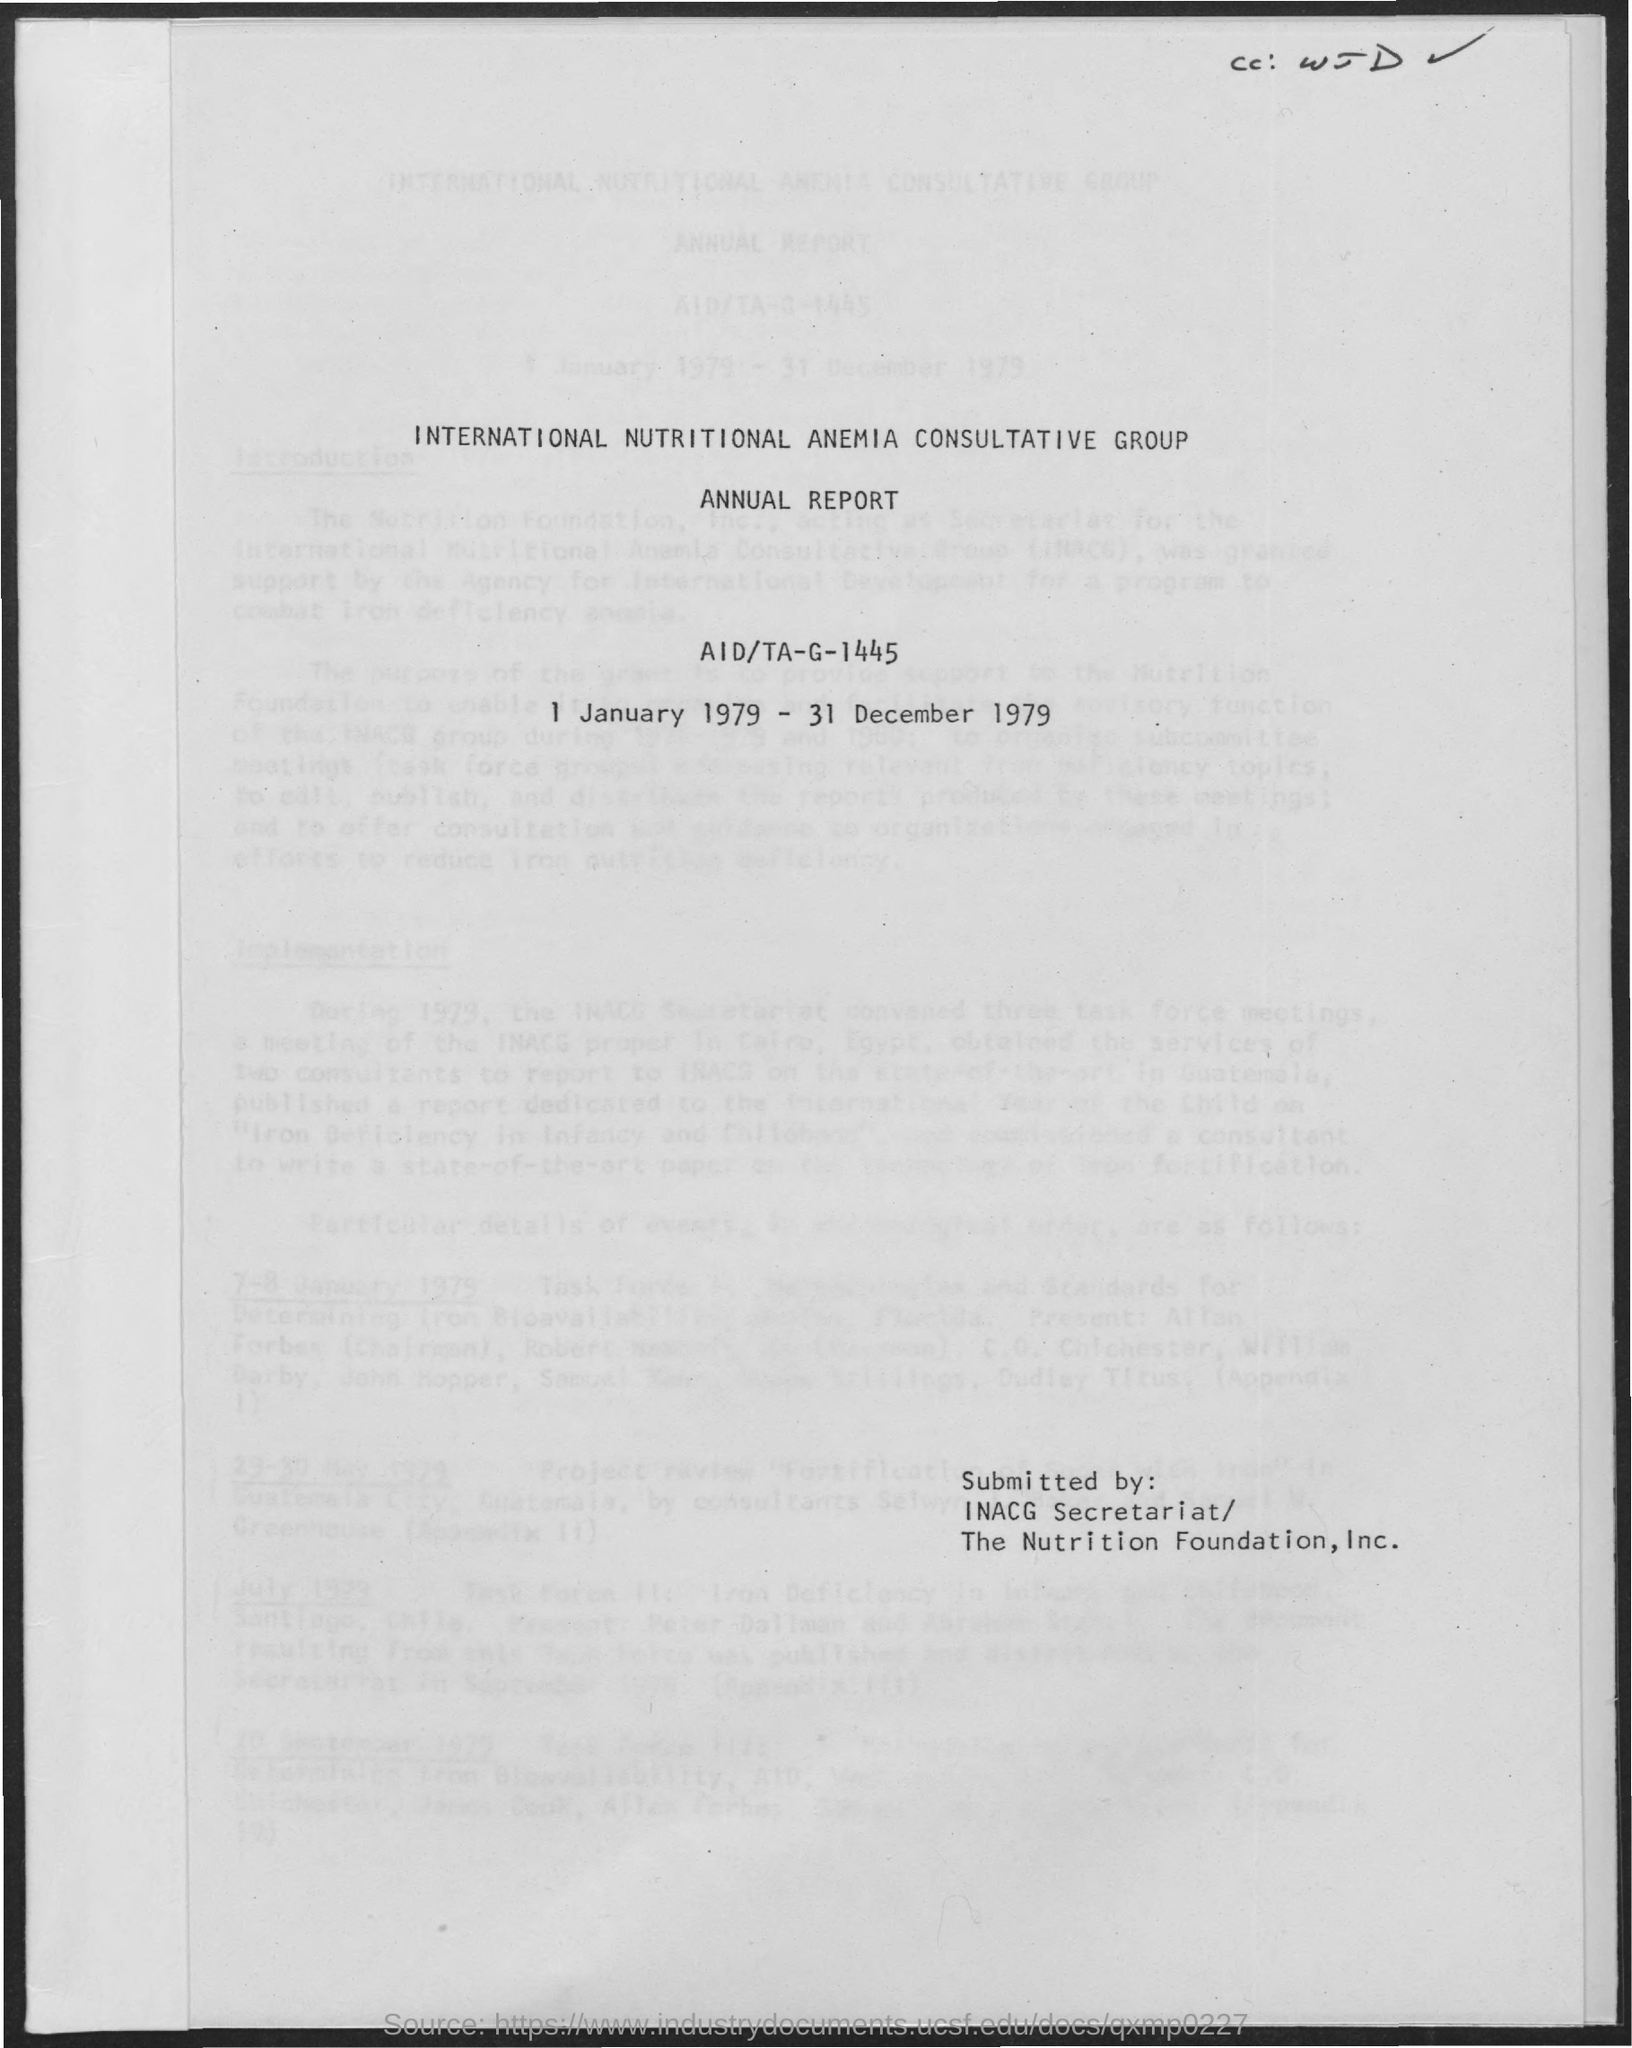Point out several critical features in this image. The International Nutritional Anemia Consultative Group, commonly referred to as INACG, is an organization dedicated to addressing the issue of nutritional anemia around the world. This annual report belongs to the period of 1 January 1979 to 31 December 1979. 